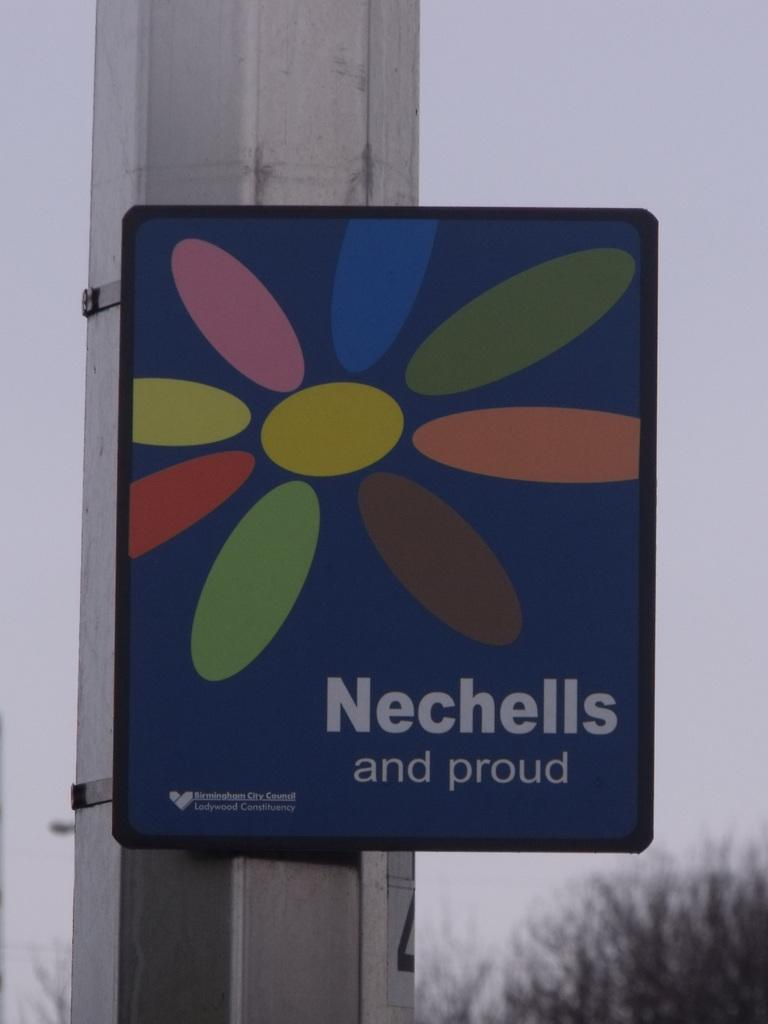Provide a one-sentence caption for the provided image. A sign with a flower with various colored petals reading Nechells and proud. 